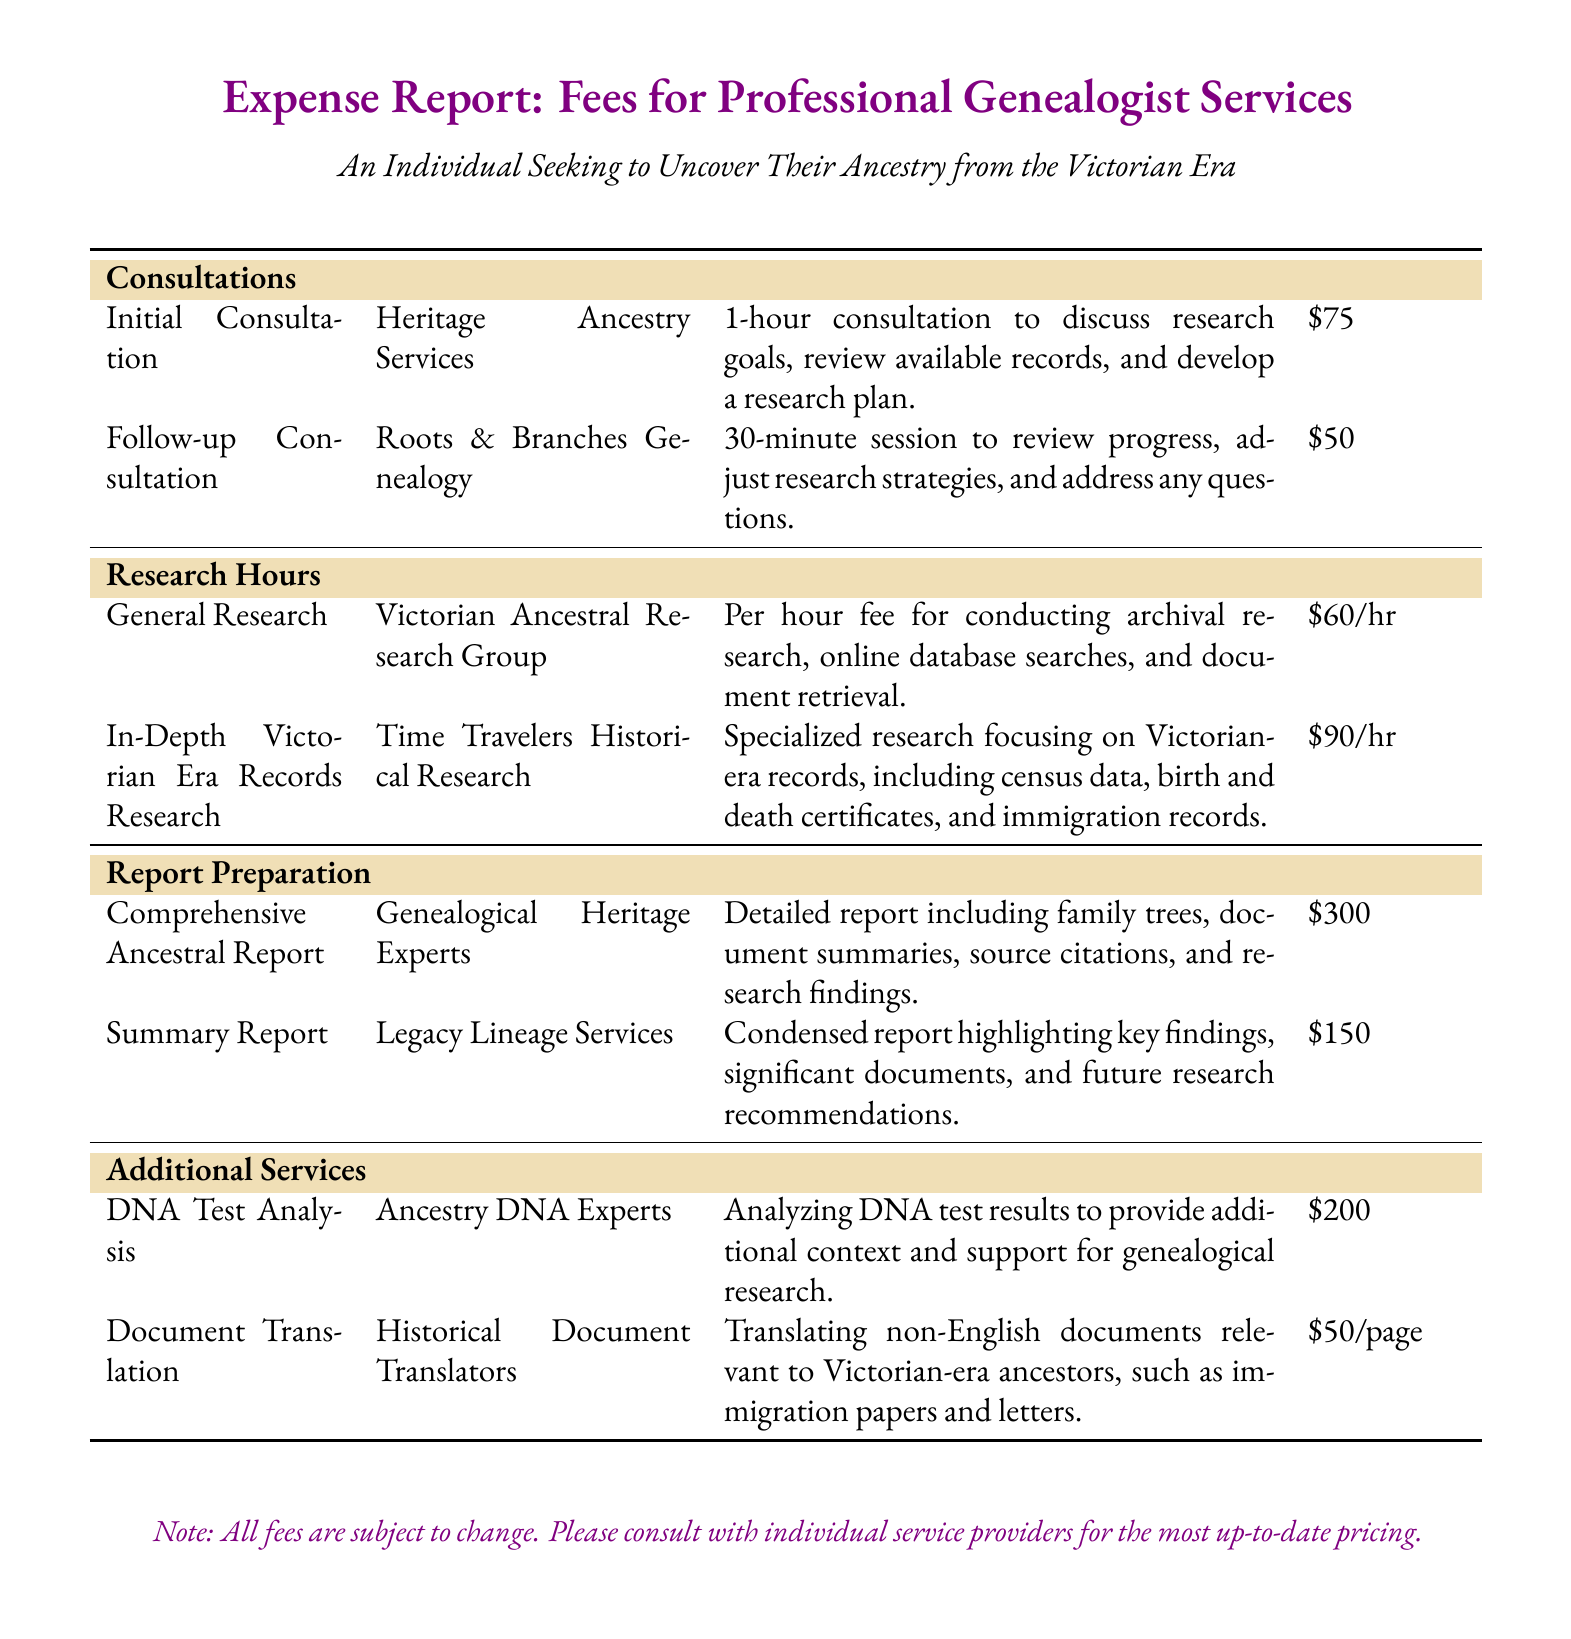What is the fee for an initial consultation? The fee for the initial consultation with Heritage Ancestry Services is listed in the document.
Answer: $75 How long is the follow-up consultation? The document specifies the duration of the follow-up consultation with Roots & Branches Genealogy.
Answer: 30 minutes What is the hourly rate for general research? The document states the hourly fee for conducting general research by Victorian Ancestral Research Group.
Answer: $60/hr Which service specializes in Victorian-era records research? The document identifies Time Travelers Historical Research as the provider for specialized Victorian-era records research.
Answer: Time Travelers Historical Research How much does a comprehensive ancestral report cost? The document details the cost for a comprehensive ancestral report from Genealogical Heritage Experts.
Answer: $300 What additional service costs $200? The document lists DNA test analysis as an additional service with a specified fee.
Answer: DNA Test Analysis What is the price per page for document translation? The document provides the cost per page for translating non-English documents.
Answer: $50/page How many different genealogist services are listed in the report? The document includes various services across different categories of consultations, research, and reports.
Answer: 8 Which report type highlights key findings and future recommendations? The document states that the summary report from Legacy Lineage Services serves this purpose.
Answer: Summary Report 